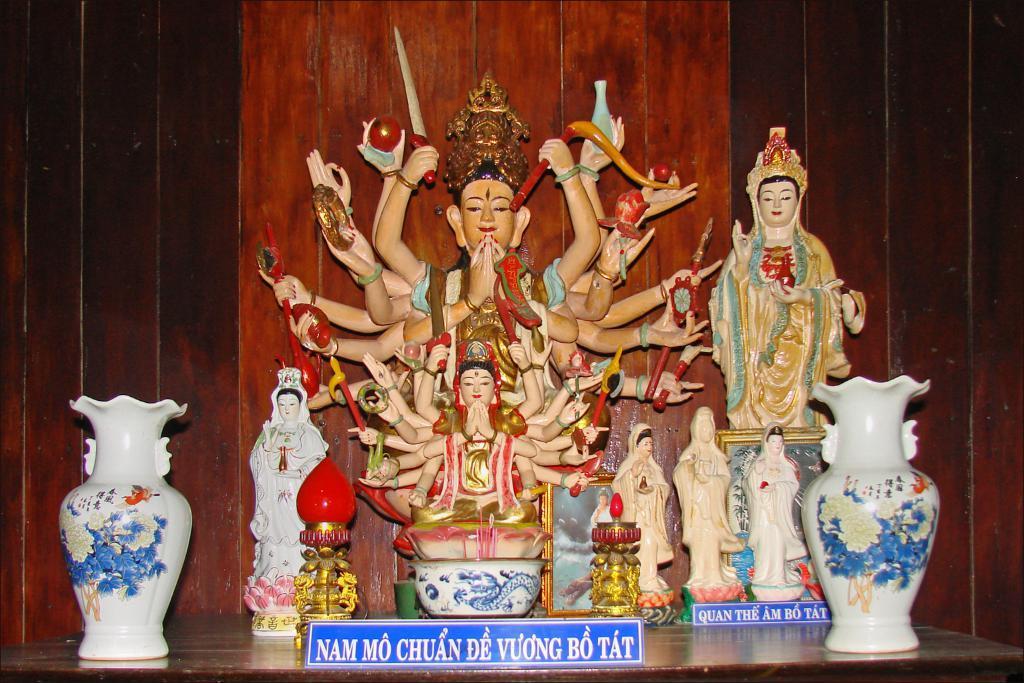Could you give a brief overview of what you see in this image? In the picture I can see two white color flower vases on the either side of the image which is placed on the surface. Here I can see two blue color boards on which I can see some text is written and here I can see few statues and in the background, I can see the wooden wall. 